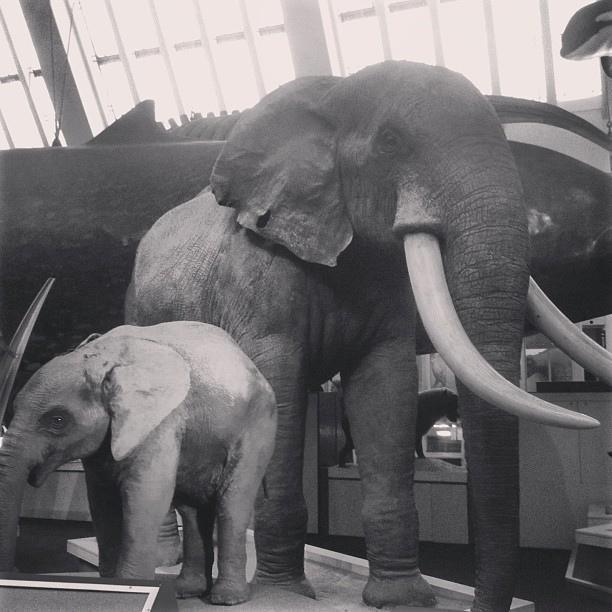How many tusks are in this picture?
Give a very brief answer. 2. How many elephants are visible?
Give a very brief answer. 2. 